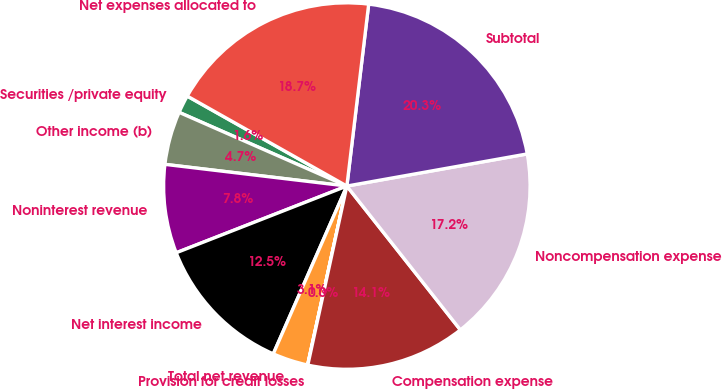Convert chart. <chart><loc_0><loc_0><loc_500><loc_500><pie_chart><fcel>Securities /private equity<fcel>Other income (b)<fcel>Noninterest revenue<fcel>Net interest income<fcel>Total net revenue<fcel>Provision for credit losses<fcel>Compensation expense<fcel>Noncompensation expense<fcel>Subtotal<fcel>Net expenses allocated to<nl><fcel>1.58%<fcel>4.7%<fcel>7.82%<fcel>12.49%<fcel>3.14%<fcel>0.02%<fcel>14.05%<fcel>17.17%<fcel>20.29%<fcel>18.73%<nl></chart> 